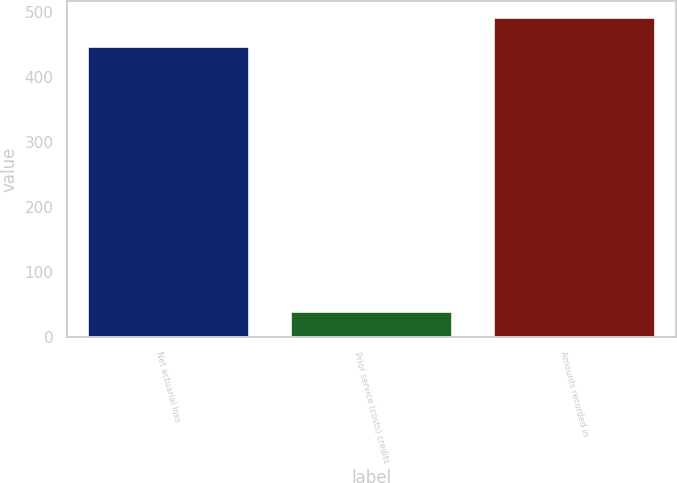<chart> <loc_0><loc_0><loc_500><loc_500><bar_chart><fcel>Net actuarial loss<fcel>Prior service (costs) credits<fcel>Amounts recorded in<nl><fcel>448.5<fcel>40.7<fcel>493.35<nl></chart> 